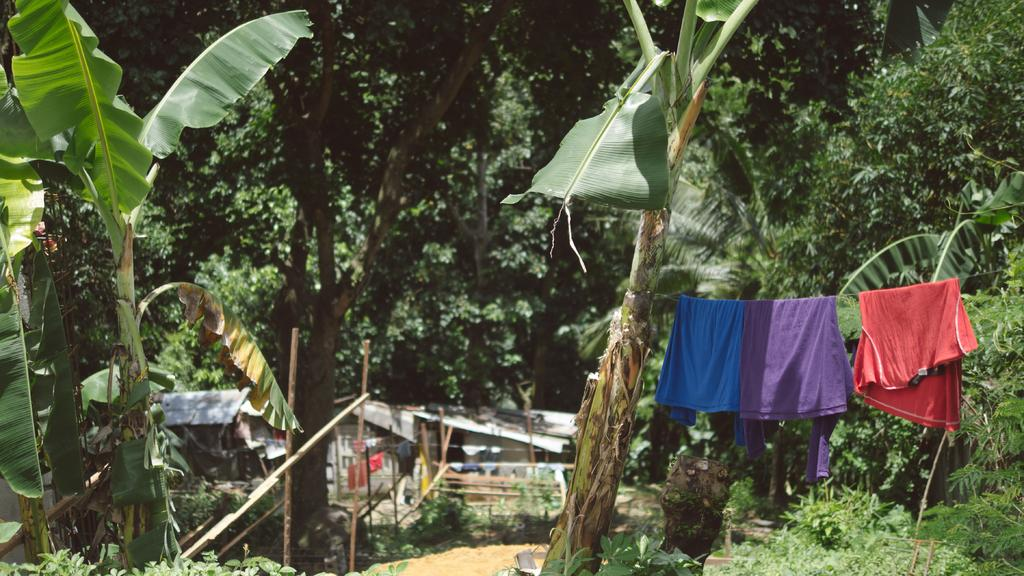What can be seen on the right side of the image? There are clothes on the right side of the image. What type of natural elements are present in the image? There are trees in the image. What type of structures can be seen in the background of the image? There are sheds and a hut in the background of the image. How many boys are playing with the toad in the image? There are no boys or toads present in the image. What type of religious symbol can be seen in the image? There is no religious symbol present in the image. 